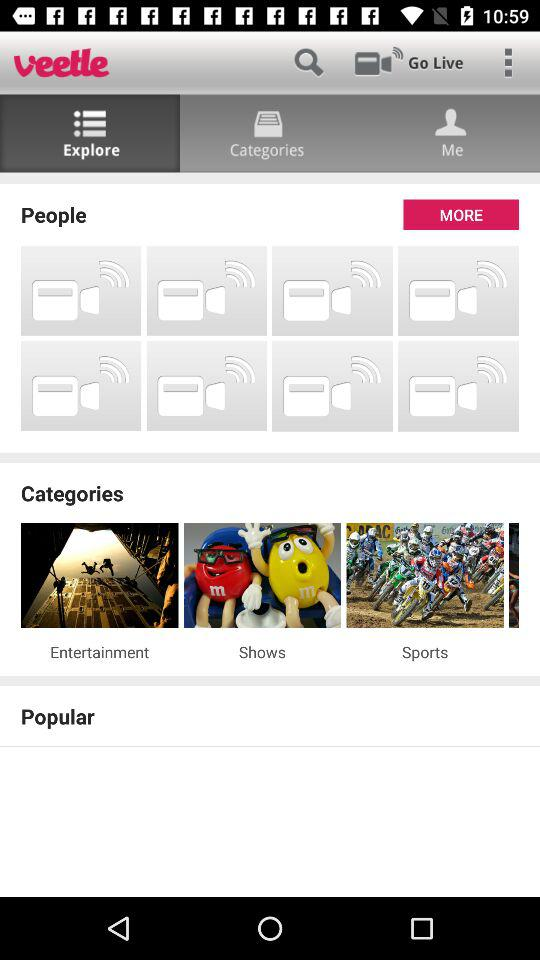What are the given categories? The given categories are entertainment, shows and sports. 